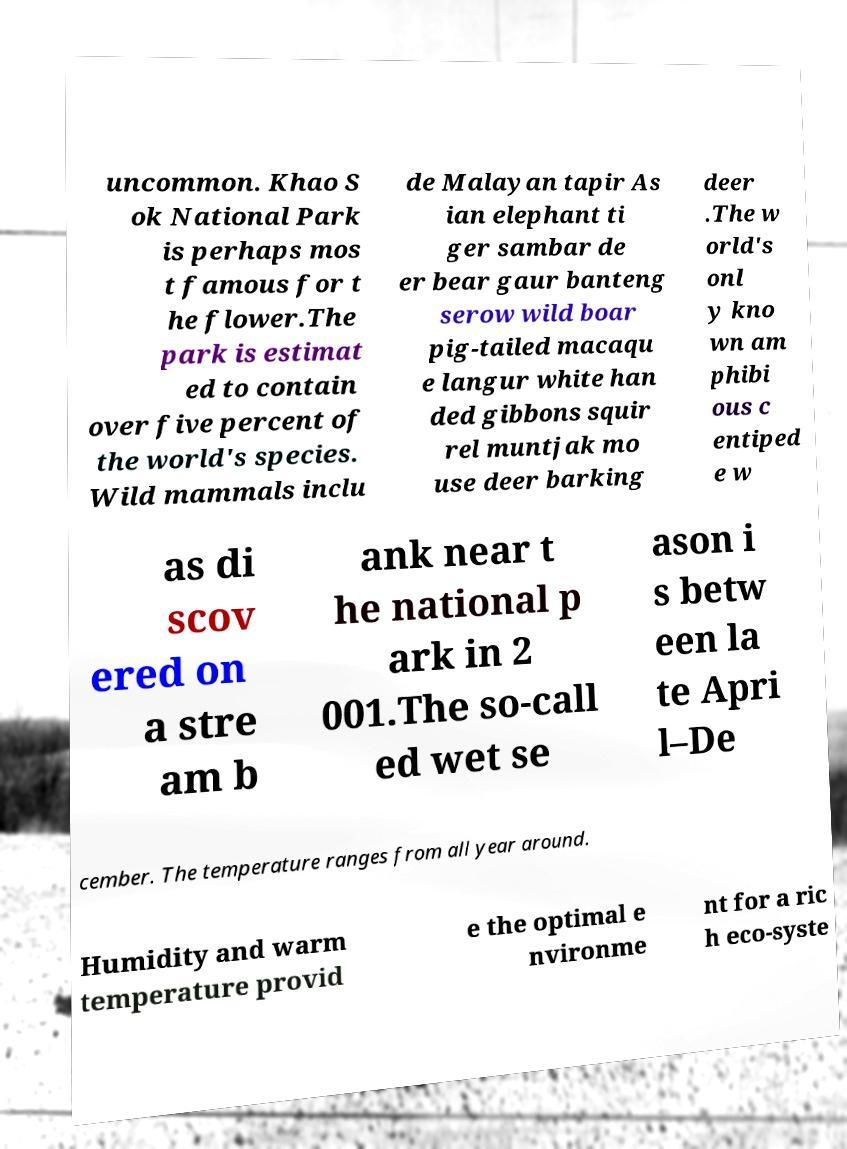Please read and relay the text visible in this image. What does it say? uncommon. Khao S ok National Park is perhaps mos t famous for t he flower.The park is estimat ed to contain over five percent of the world's species. Wild mammals inclu de Malayan tapir As ian elephant ti ger sambar de er bear gaur banteng serow wild boar pig-tailed macaqu e langur white han ded gibbons squir rel muntjak mo use deer barking deer .The w orld's onl y kno wn am phibi ous c entiped e w as di scov ered on a stre am b ank near t he national p ark in 2 001.The so-call ed wet se ason i s betw een la te Apri l–De cember. The temperature ranges from all year around. Humidity and warm temperature provid e the optimal e nvironme nt for a ric h eco-syste 